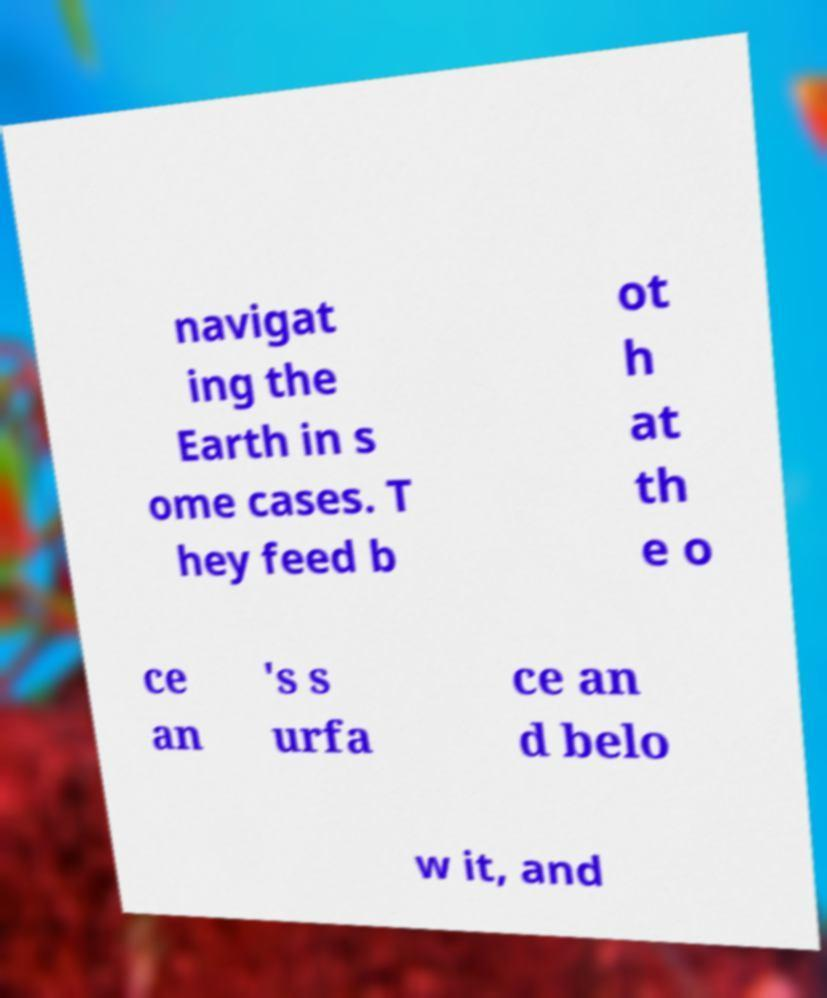For documentation purposes, I need the text within this image transcribed. Could you provide that? navigat ing the Earth in s ome cases. T hey feed b ot h at th e o ce an 's s urfa ce an d belo w it, and 